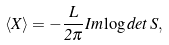<formula> <loc_0><loc_0><loc_500><loc_500>\langle X \rangle = - \frac { L } { 2 \pi } I m \log d e t \, S ,</formula> 